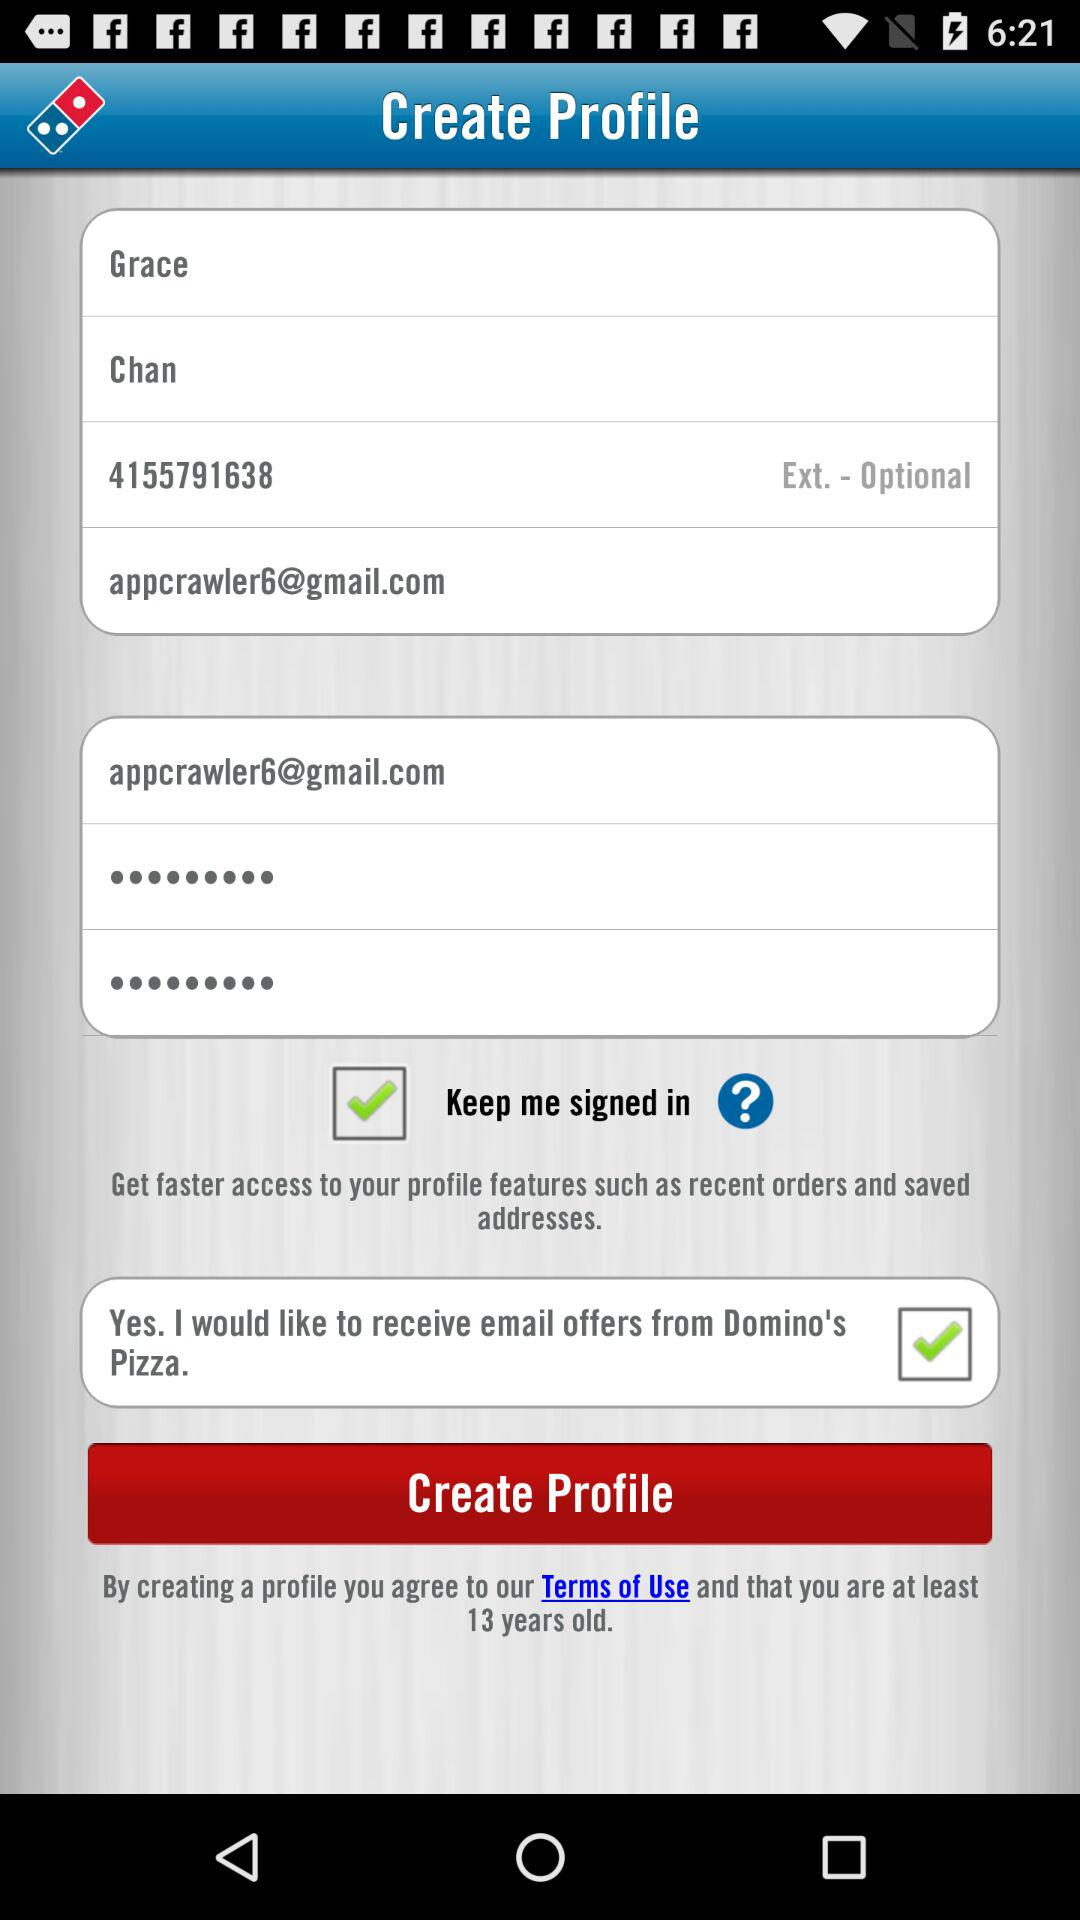What contact number is shown on the screen? The contact number shown on the screen is 4155791638. 